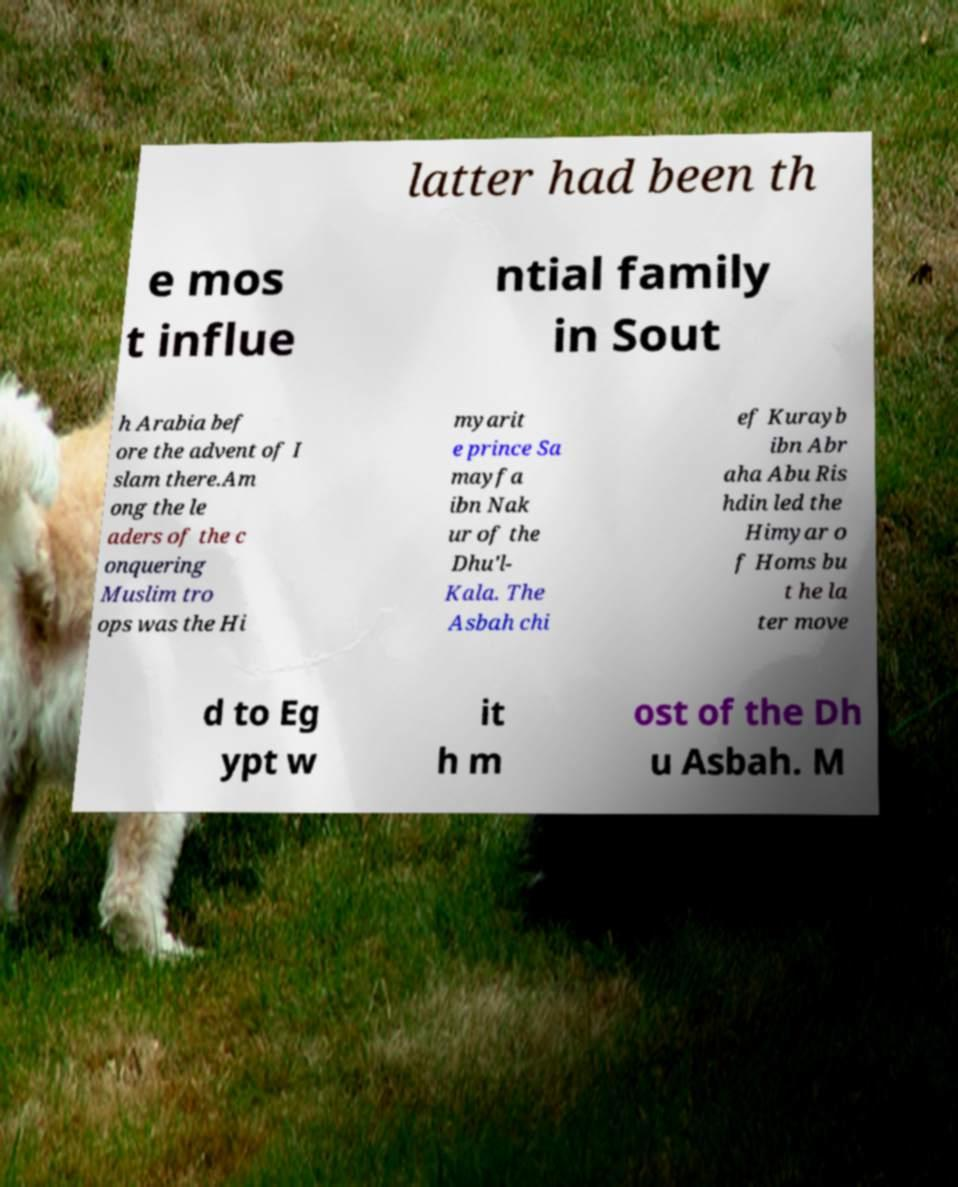Could you extract and type out the text from this image? latter had been th e mos t influe ntial family in Sout h Arabia bef ore the advent of I slam there.Am ong the le aders of the c onquering Muslim tro ops was the Hi myarit e prince Sa mayfa ibn Nak ur of the Dhu'l- Kala. The Asbah chi ef Kurayb ibn Abr aha Abu Ris hdin led the Himyar o f Homs bu t he la ter move d to Eg ypt w it h m ost of the Dh u Asbah. M 